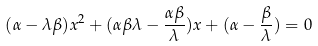Convert formula to latex. <formula><loc_0><loc_0><loc_500><loc_500>( \alpha - \lambda \beta ) x ^ { 2 } + ( \alpha \beta \lambda - \frac { \alpha \beta } { \lambda } ) x + ( \alpha - \frac { \beta } { \lambda } ) = 0</formula> 